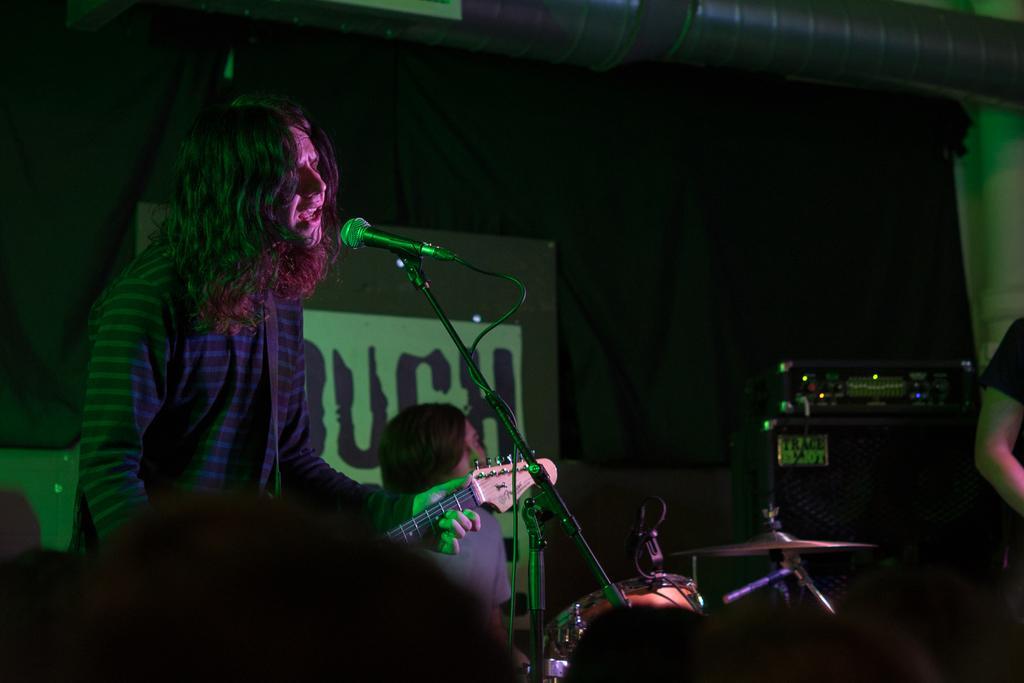In one or two sentences, can you explain what this image depicts? In this picture I can see a person singing with the help of a microphone and he is playing guitar and another person playing drums and I can see a human hand on the right side of the picture and I can see a board with some text and a black cloth in the background and looks like an amplifier on the top right corner. 